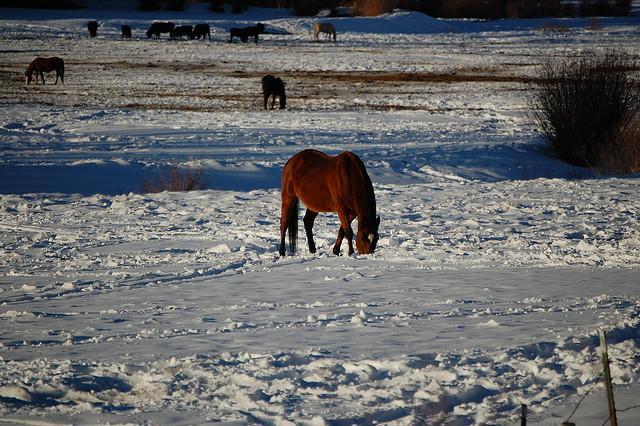How many bears are there?
Give a very brief answer. 0. 